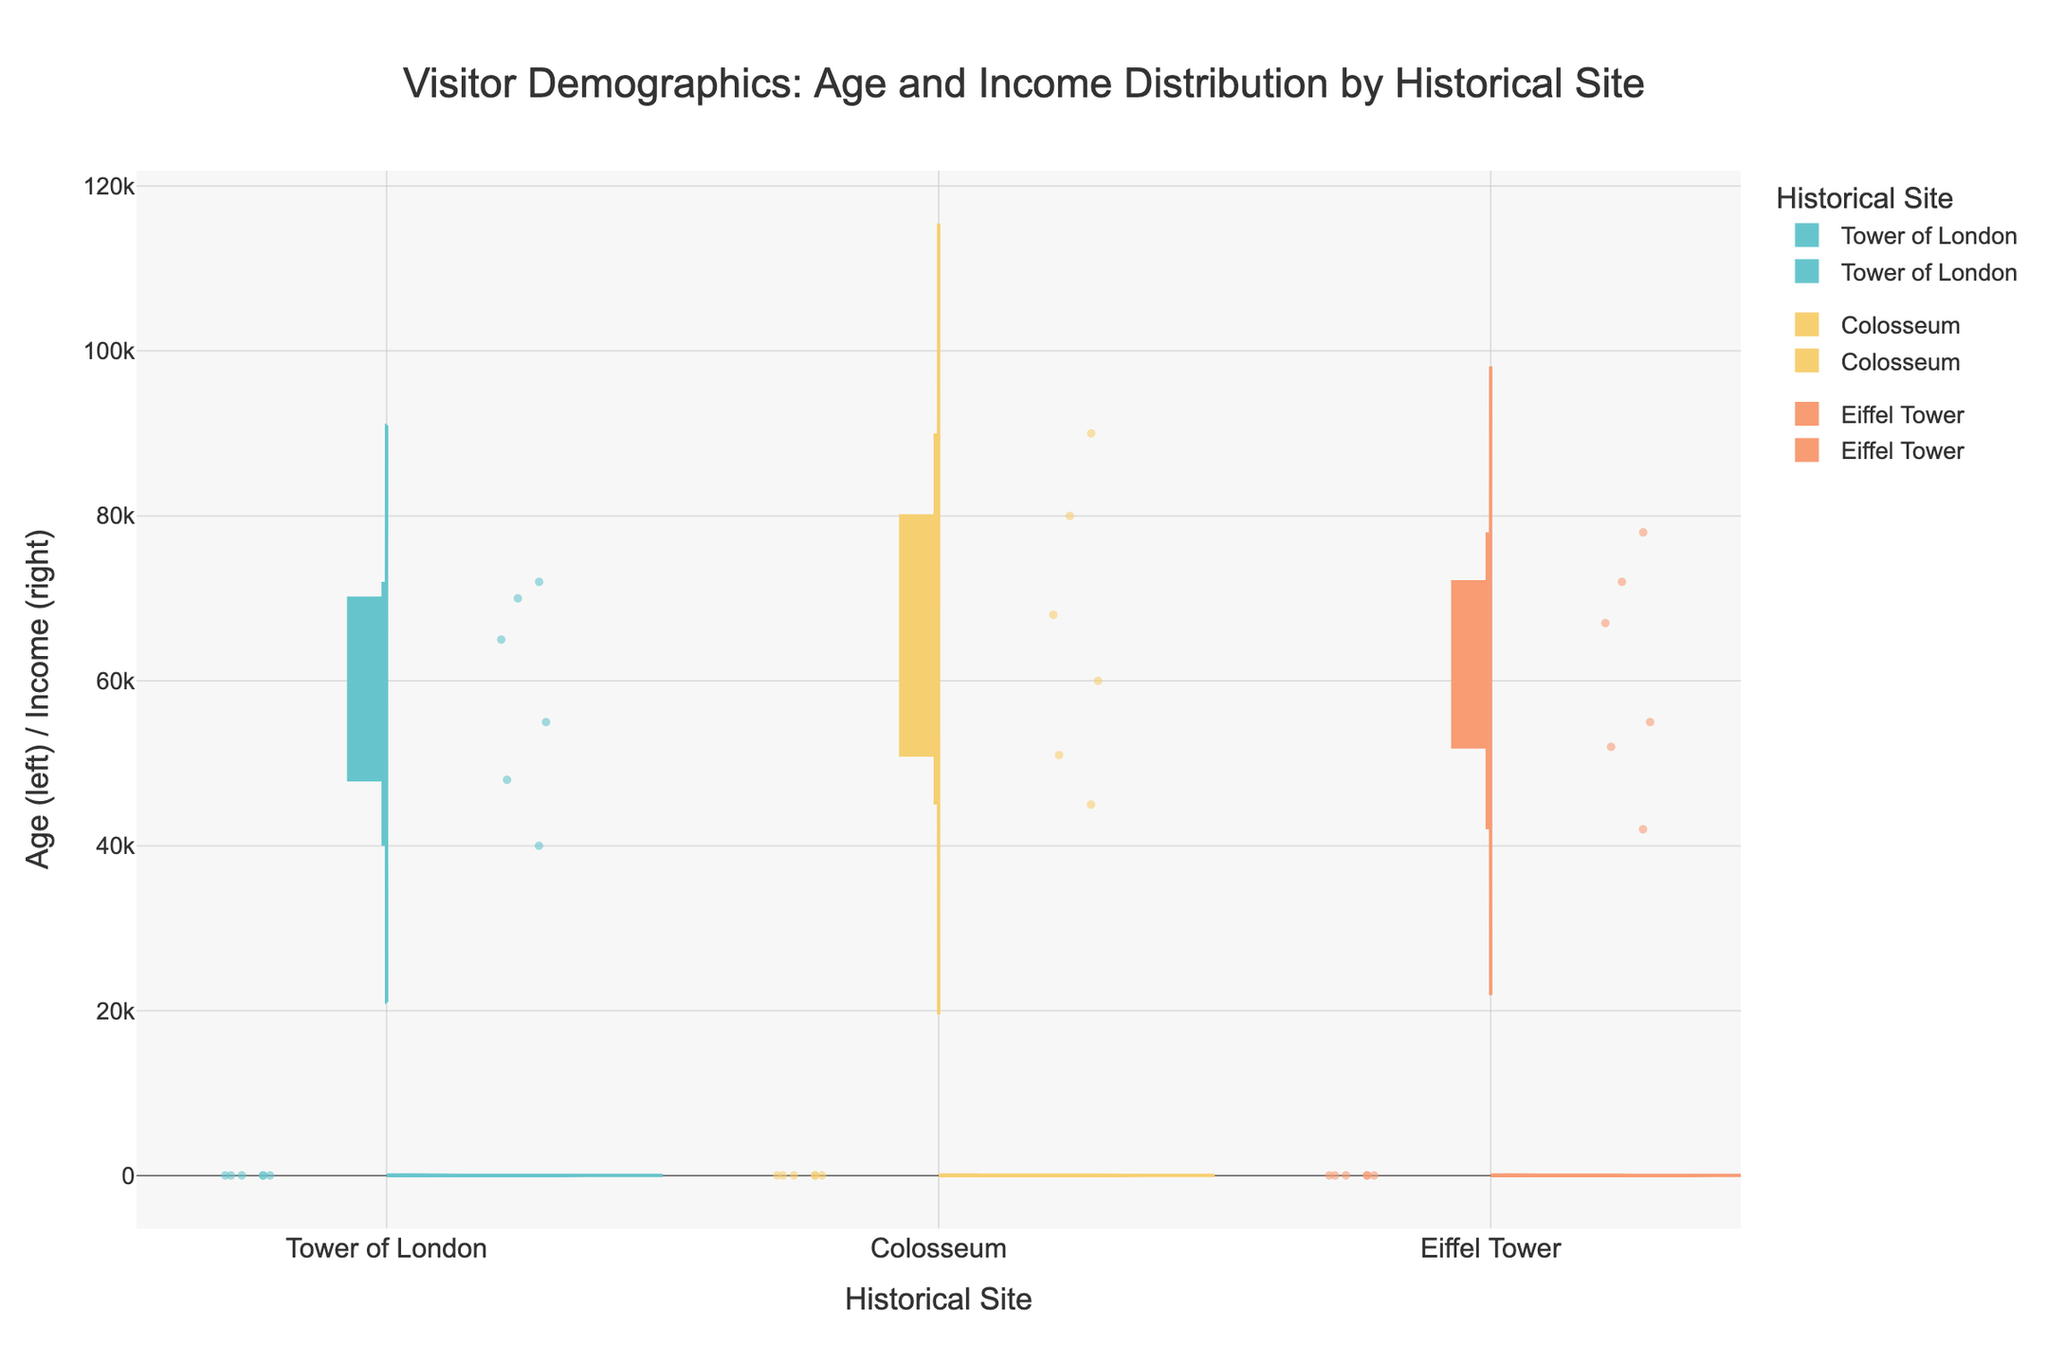What is the title of the figure? The title is usually placed at the top of the figure, specifying the main focus of the visualization. In this case, it is "Visitor Demographics: Age and Income Distribution by Historical Site".
Answer: Visitor Demographics: Age and Income Distribution by Historical Site How are the age and income distributions distinguished on the plot? The age and income distributions are distinguished by their position on the violin plot: age distributions are shown on the left side, and income distributions are on the right side. The titles on the y-axis also indicate "Age (left) / Income (right)”.
Answer: Age on the left, Income on the right Which site has the highest mean income distribution according to the figure? To determine this, examine the mean lines within the right-side violin plots of each site. The mean line is shown within the income distribution of the Tower of London, Colosseum, and Eiffel Tower. The site with the highest line on the income side will indicate the highest mean income.
Answer: Colosseum What is the average age of visitors to the Eiffel Tower in 2022? First, identify the violin plot for the Eiffel Tower and locate the data points within the '2022' group. Then, average these ages visually by estimating the central tendency within the points collected for the year 2022 on the left side of the plot.
Answer: Approximately 39 Do visitors to the Tower of London have more varied ages or incomes? Look at the spread (width) of the violin plots for age and income for the Tower of London. The side (age or income) with the wider distribution indicates more variability. A wider spread shows greater variation.
Answer: Ages How does the age range of Colosseum visitors compare between 2021 and 2022? Compare the left-side violin plots of the Colosseum for 2021 and 2022, focusing on the spread from the minimum to maximum data points. Note the length and spread of the violins for both years.
Answer: Slightly wider in 2022 Which historical site shows the most significant change in visitor income distributions before and after restoration? Look at the right-side violin plots of all sites and compare their spread and mean lines for the years before and after restoration (2021 vs. 2022). The site with the most notable shift or change in income distribution will be the answer.
Answer: Eiffel Tower What is the median income value of visitors to the Tower of London in 2022? To find the median income, look at the income violin plot for the Tower of London in 2022 and identify the central point of the data points. The median is marked by a line or can be estimated by finding the midpoint in the density of the income distribution curve.
Answer: Approximately 65000 Do male or female visitors generally have higher incomes at the Colosseum? This question requires identifying the gender of visitors from income data points. However, since the violin plots do not differentiate by gender within income distributions directly, this information is not visible from the plot alone.
Answer: Not distinguishable in the figure 